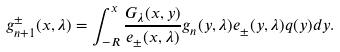Convert formula to latex. <formula><loc_0><loc_0><loc_500><loc_500>g _ { n + 1 } ^ { \pm } ( x , { \lambda } ) = \int _ { - R } ^ { x } \frac { G _ { \lambda } ( x , y ) } { e _ { \pm } ( x , { \lambda } ) } g _ { n } ( y , { \lambda } ) e _ { \pm } ( y , { \lambda } ) q ( y ) d y .</formula> 